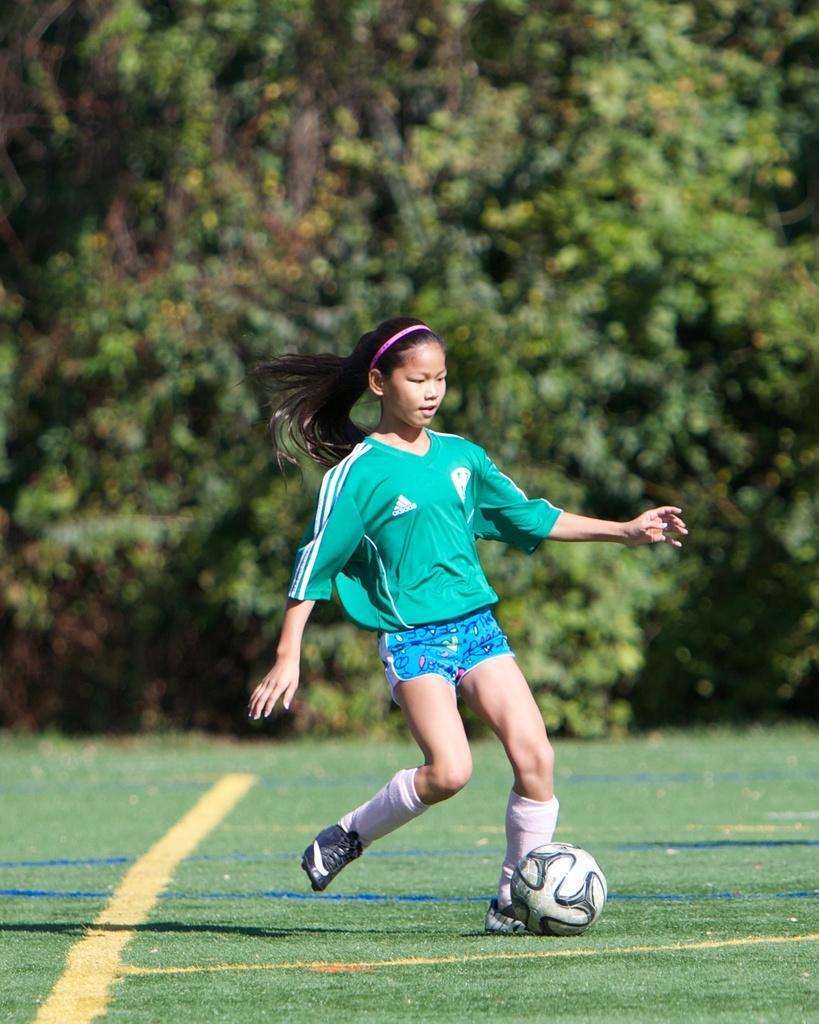In one or two sentences, can you explain what this image depicts? On the background we can see trees. here we can see one girl is playing a football in a ground. She wore pink colour hair band. 